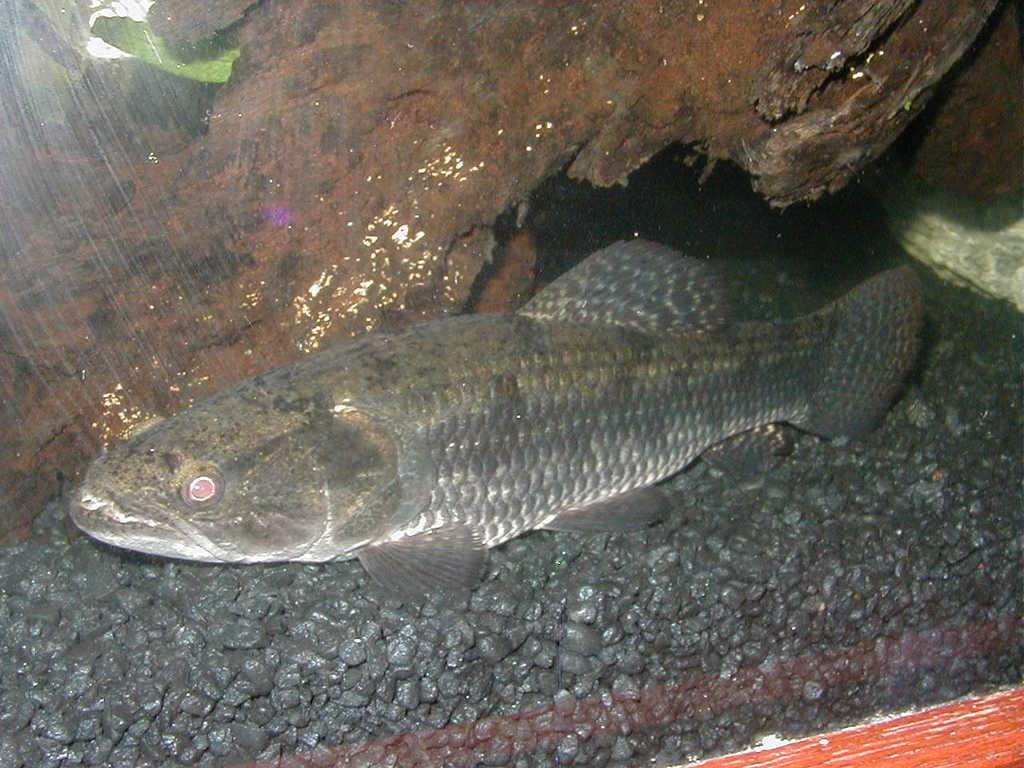What type of animal can be seen in the water in the image? There is a fish in the water in the image. What other object can be seen in the image? There is a rock in the image. How does the society of fish in the image perform addition? There is no indication of a society of fish or any mathematical operations in the image. 